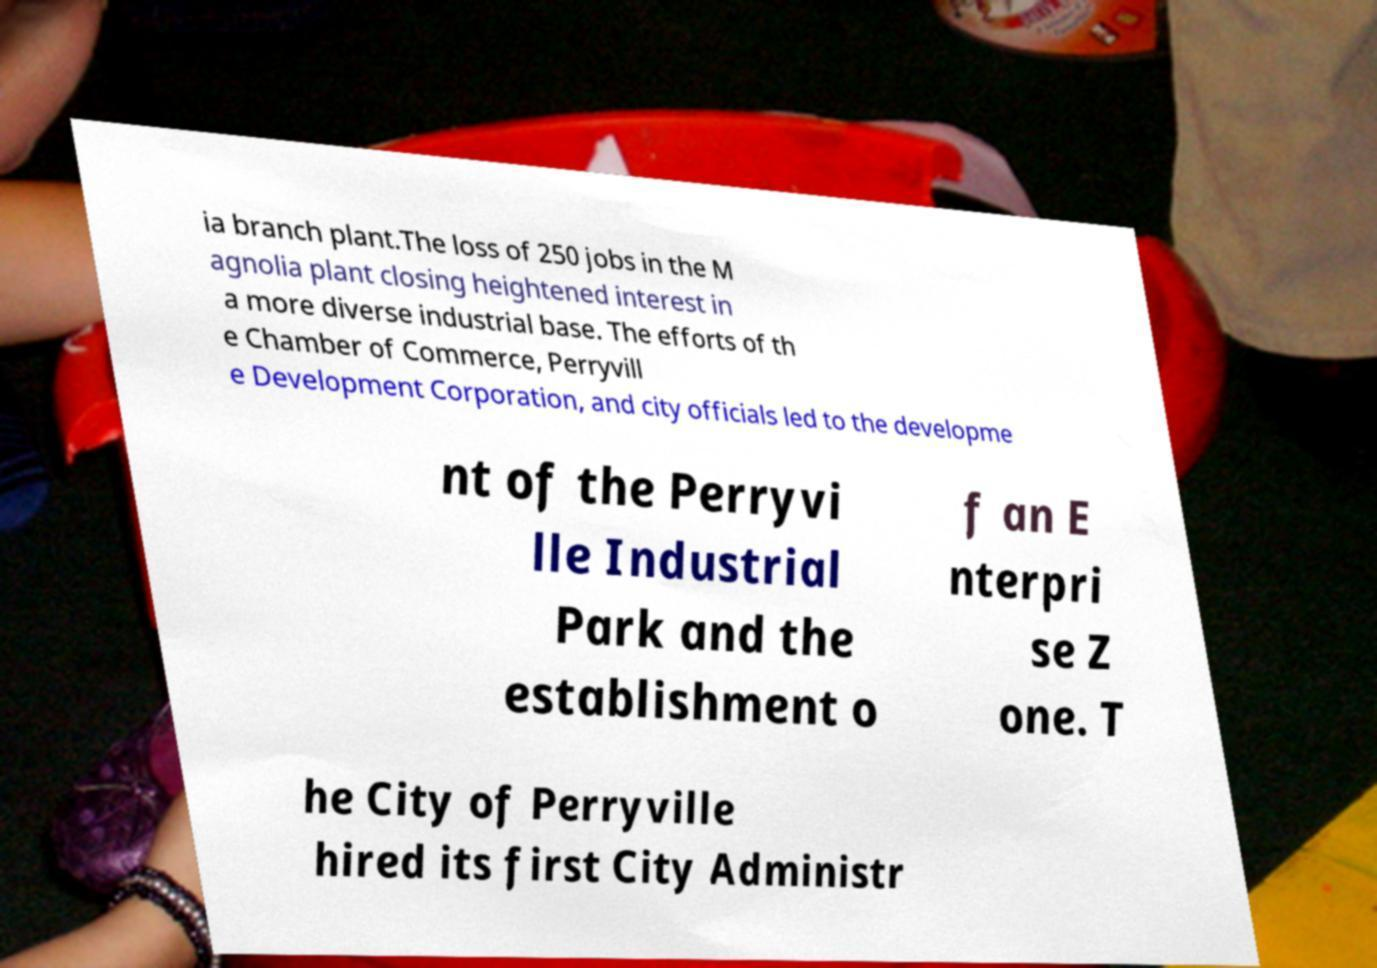Can you accurately transcribe the text from the provided image for me? ia branch plant.The loss of 250 jobs in the M agnolia plant closing heightened interest in a more diverse industrial base. The efforts of th e Chamber of Commerce, Perryvill e Development Corporation, and city officials led to the developme nt of the Perryvi lle Industrial Park and the establishment o f an E nterpri se Z one. T he City of Perryville hired its first City Administr 